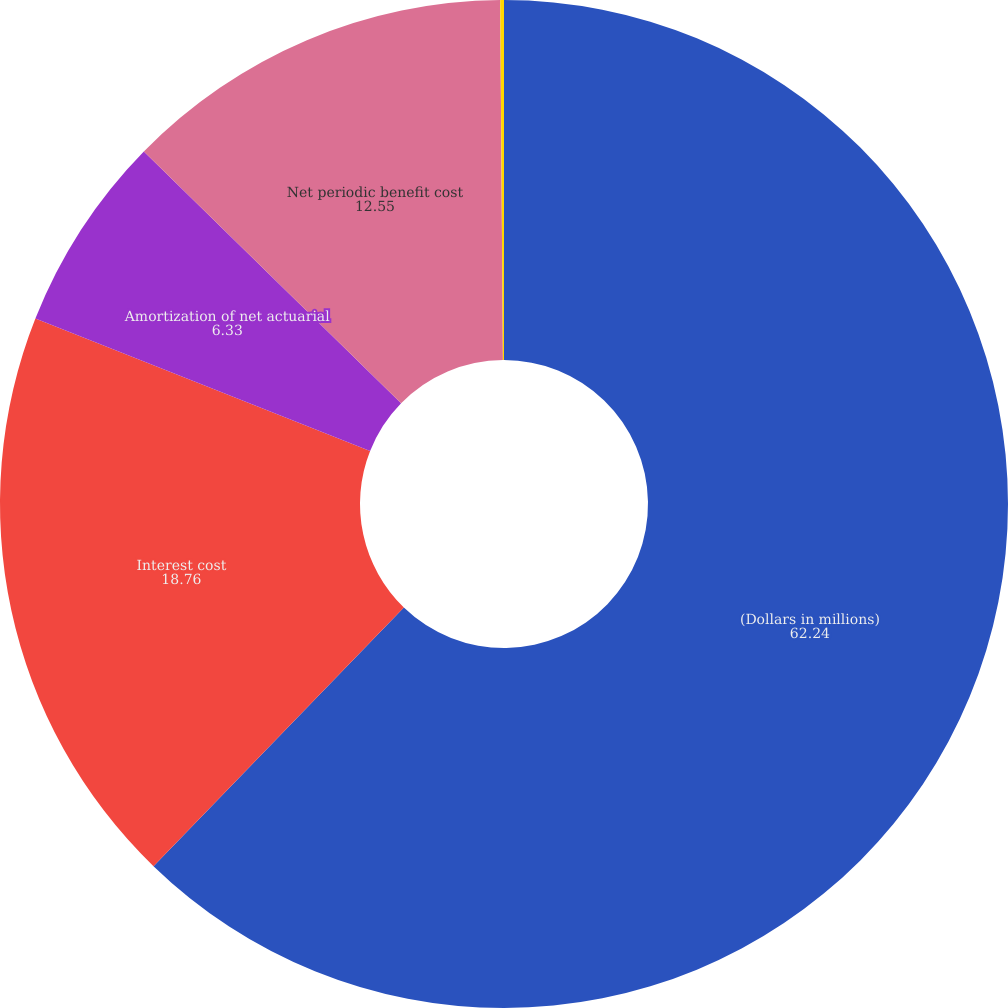Convert chart. <chart><loc_0><loc_0><loc_500><loc_500><pie_chart><fcel>(Dollars in millions)<fcel>Interest cost<fcel>Amortization of net actuarial<fcel>Net periodic benefit cost<fcel>Discount rate<nl><fcel>62.24%<fcel>18.76%<fcel>6.33%<fcel>12.55%<fcel>0.12%<nl></chart> 